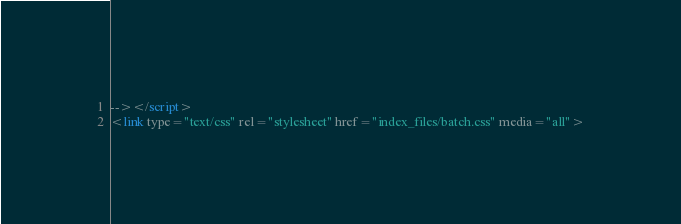<code> <loc_0><loc_0><loc_500><loc_500><_HTML_>--></script>
<link type="text/css" rel="stylesheet" href="index_files/batch.css" media="all"></code> 